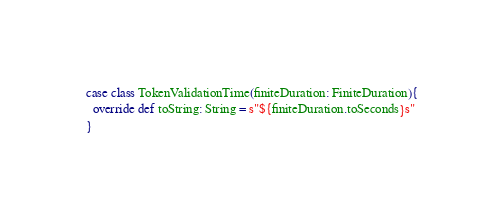Convert code to text. <code><loc_0><loc_0><loc_500><loc_500><_Scala_>
case class TokenValidationTime(finiteDuration: FiniteDuration){
  override def toString: String = s"${finiteDuration.toSeconds}s"
}
</code> 